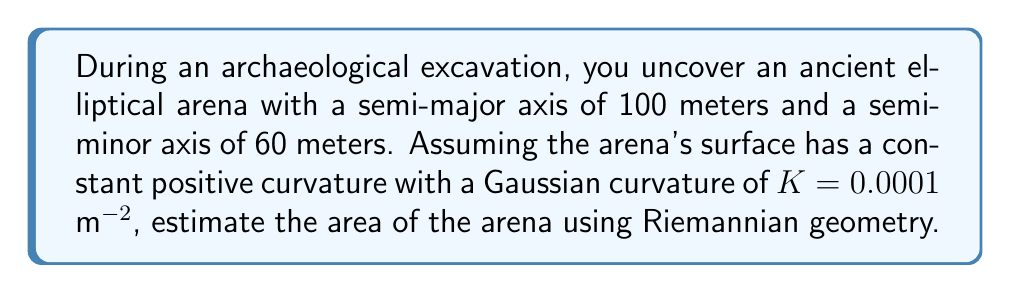Teach me how to tackle this problem. To estimate the area of the elliptical arena using Riemannian geometry, we'll follow these steps:

1) In Riemannian geometry, the area of a surface with constant positive curvature $K$ is given by:

   $$A = \frac{2\pi}{K} \left(1 - \cos\left(\sqrt{K}r\right)\right)$$

   where $r$ is the radius of the geodesic circle with the same area as our ellipse.

2) For an ellipse with semi-major axis $a$ and semi-minor axis $b$, the area in Euclidean geometry is:

   $$A_{E} = \pi ab$$

3) Substitute the given values:

   $$A_{E} = \pi(100)(60) = 6000\pi \approx 18849.56 \text{ m}^2$$

4) To find $r$, we equate this area to the formula for a circle's area:

   $$\pi r^2 = 6000\pi$$
   $$r^2 = 6000$$
   $$r = \sqrt{6000} \approx 77.46 \text{ m}$$

5) Now we can use the Riemannian area formula:

   $$A = \frac{2\pi}{0.0001} \left(1 - \cos\left(\sqrt{0.0001}(77.46)\right)\right)$$

6) Simplify:

   $$A = 62831.85 \left(1 - \cos(0.02449)\right)$$
   $$A = 62831.85 (0.0003)$$
   $$A \approx 18.85 \text{ m}^2$$

7) The difference between this result and the Euclidean area represents the effect of the surface's curvature on the total area.
Answer: $18.85 \text{ m}^2$ 